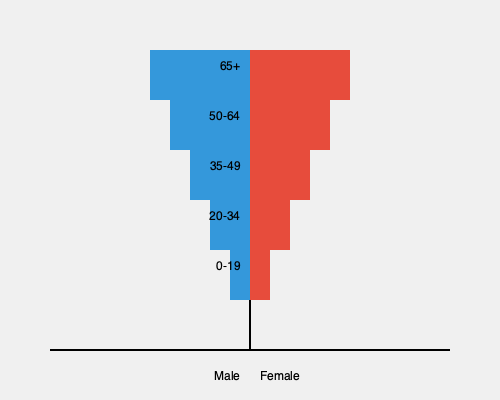As a documentary filmmaker, you've created a population pyramid to visualize your target audience demographics. What key insight about the age distribution can you derive from this visualization, and how might it influence your content strategy to maximize engagement across different age groups? To analyze this population pyramid and derive insights for content strategy, we need to follow these steps:

1. Understand the structure:
   - The left side represents males, the right side females.
   - Each bar represents an age group, with younger ages at the bottom and older at the top.
   - The width of each bar indicates the population size for that age-gender group.

2. Observe the distribution:
   - The pyramid is relatively symmetric, indicating a balanced gender distribution.
   - The widest bars are in the middle, representing ages 35-49 and 50-64.
   - There's a gradual decrease in bar width towards the top (older ages) and bottom (younger ages).

3. Interpret the data:
   - The audience has a higher concentration of middle-aged and older adults.
   - There's a smaller proportion of young adults (20-34) and children/teens (0-19).
   - The 65+ age group is the smallest but still significant.

4. Content strategy implications:
   - Focus on topics and themes that resonate with middle-aged and older adults (35-64).
   - Create content that appeals to both genders, as the distribution is balanced.
   - Consider multi-generational content to engage the smaller but present younger and older demographics.
   - Use storytelling techniques that connect with life experiences of the 35-64 age group.
   - Incorporate historical context or nostalgic elements that might appeal to the older audience segments.

5. Engagement maximization:
   - Develop a primary focus on the 35-64 age range, where the majority of the audience lies.
   - Create supplementary content for the 20-34 and 65+ groups to ensure inclusive engagement.
   - Use diverse interview subjects and experts that represent various age groups to provide different perspectives.
   - Employ a mix of traditional and digital distribution channels to reach all age segments effectively.

The key insight is that the audience has a higher concentration of middle-aged and older adults, with a balanced gender distribution. This should drive a content strategy that primarily caters to the 35-64 age range while including elements that can engage younger and older viewers.
Answer: Focus on content for ages 35-64, with balanced gender appeal and supplementary elements for younger and older demographics. 